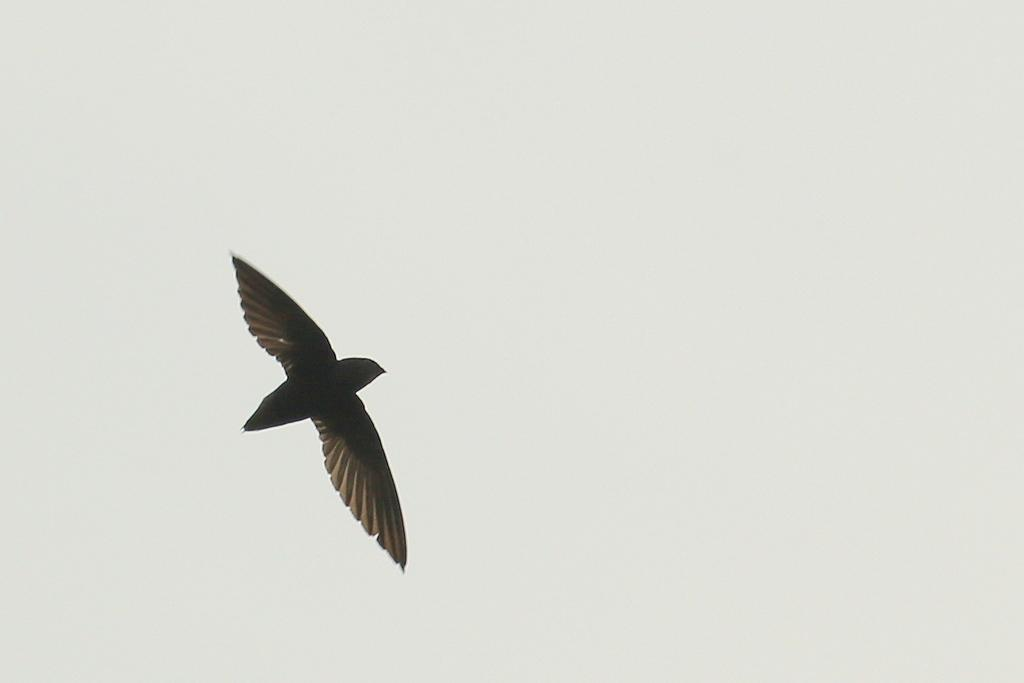What type of animal can be seen in the image? There is a bird in the image. What part of the natural environment is visible in the image? The sky is visible in the image. What type of drum is the bird playing in the image? There is no drum present in the image; it features a bird and the sky. How many geese are visible in the image? There are no geese present in the image; it features a bird and the sky. 